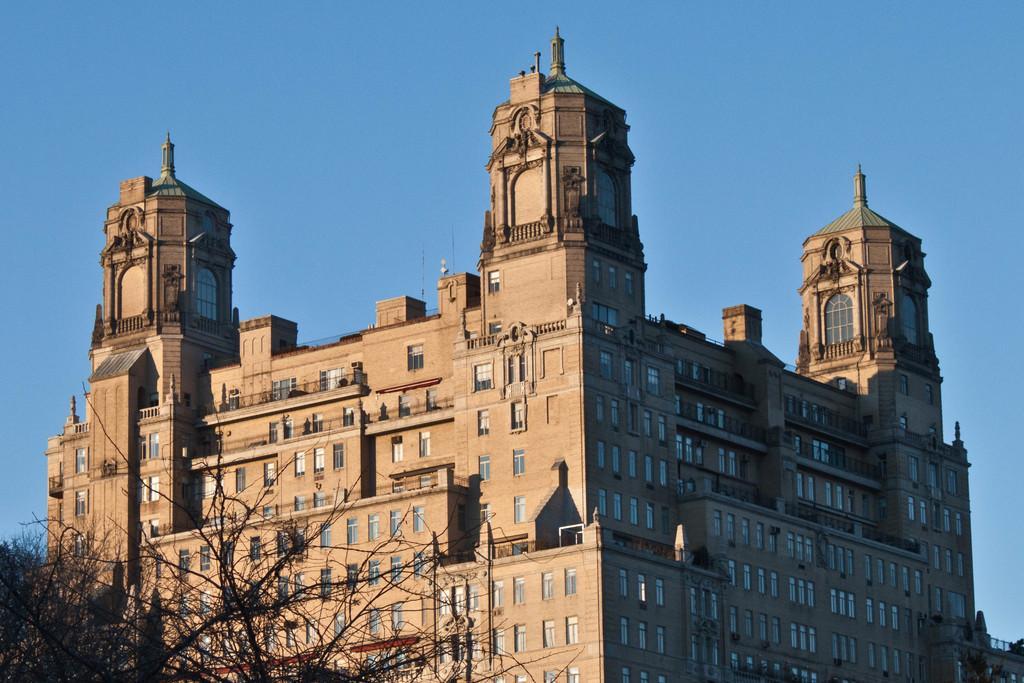How would you summarize this image in a sentence or two? This image consists of a building along with windows. On the left, there is a tree. At the top, there is sky. 